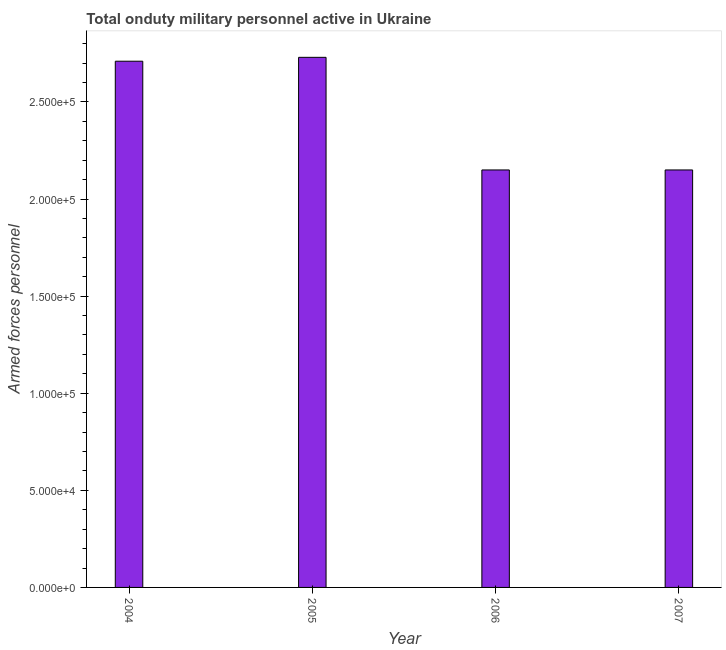Does the graph contain grids?
Provide a succinct answer. No. What is the title of the graph?
Provide a short and direct response. Total onduty military personnel active in Ukraine. What is the label or title of the Y-axis?
Give a very brief answer. Armed forces personnel. What is the number of armed forces personnel in 2007?
Your response must be concise. 2.15e+05. Across all years, what is the maximum number of armed forces personnel?
Your answer should be very brief. 2.73e+05. Across all years, what is the minimum number of armed forces personnel?
Keep it short and to the point. 2.15e+05. What is the sum of the number of armed forces personnel?
Ensure brevity in your answer.  9.74e+05. What is the average number of armed forces personnel per year?
Your response must be concise. 2.44e+05. What is the median number of armed forces personnel?
Provide a succinct answer. 2.43e+05. Do a majority of the years between 2007 and 2005 (inclusive) have number of armed forces personnel greater than 240000 ?
Offer a terse response. Yes. What is the ratio of the number of armed forces personnel in 2005 to that in 2007?
Your answer should be very brief. 1.27. Is the number of armed forces personnel in 2006 less than that in 2007?
Give a very brief answer. No. Is the difference between the number of armed forces personnel in 2004 and 2005 greater than the difference between any two years?
Provide a short and direct response. No. What is the difference between the highest and the second highest number of armed forces personnel?
Ensure brevity in your answer.  2000. What is the difference between the highest and the lowest number of armed forces personnel?
Your response must be concise. 5.80e+04. In how many years, is the number of armed forces personnel greater than the average number of armed forces personnel taken over all years?
Your answer should be very brief. 2. How many bars are there?
Your answer should be very brief. 4. How many years are there in the graph?
Offer a very short reply. 4. What is the difference between two consecutive major ticks on the Y-axis?
Ensure brevity in your answer.  5.00e+04. What is the Armed forces personnel in 2004?
Offer a very short reply. 2.71e+05. What is the Armed forces personnel of 2005?
Offer a very short reply. 2.73e+05. What is the Armed forces personnel of 2006?
Provide a short and direct response. 2.15e+05. What is the Armed forces personnel in 2007?
Make the answer very short. 2.15e+05. What is the difference between the Armed forces personnel in 2004 and 2005?
Make the answer very short. -2000. What is the difference between the Armed forces personnel in 2004 and 2006?
Provide a short and direct response. 5.60e+04. What is the difference between the Armed forces personnel in 2004 and 2007?
Ensure brevity in your answer.  5.60e+04. What is the difference between the Armed forces personnel in 2005 and 2006?
Make the answer very short. 5.80e+04. What is the difference between the Armed forces personnel in 2005 and 2007?
Offer a terse response. 5.80e+04. What is the difference between the Armed forces personnel in 2006 and 2007?
Give a very brief answer. 0. What is the ratio of the Armed forces personnel in 2004 to that in 2006?
Offer a very short reply. 1.26. What is the ratio of the Armed forces personnel in 2004 to that in 2007?
Ensure brevity in your answer.  1.26. What is the ratio of the Armed forces personnel in 2005 to that in 2006?
Keep it short and to the point. 1.27. What is the ratio of the Armed forces personnel in 2005 to that in 2007?
Your response must be concise. 1.27. What is the ratio of the Armed forces personnel in 2006 to that in 2007?
Offer a very short reply. 1. 